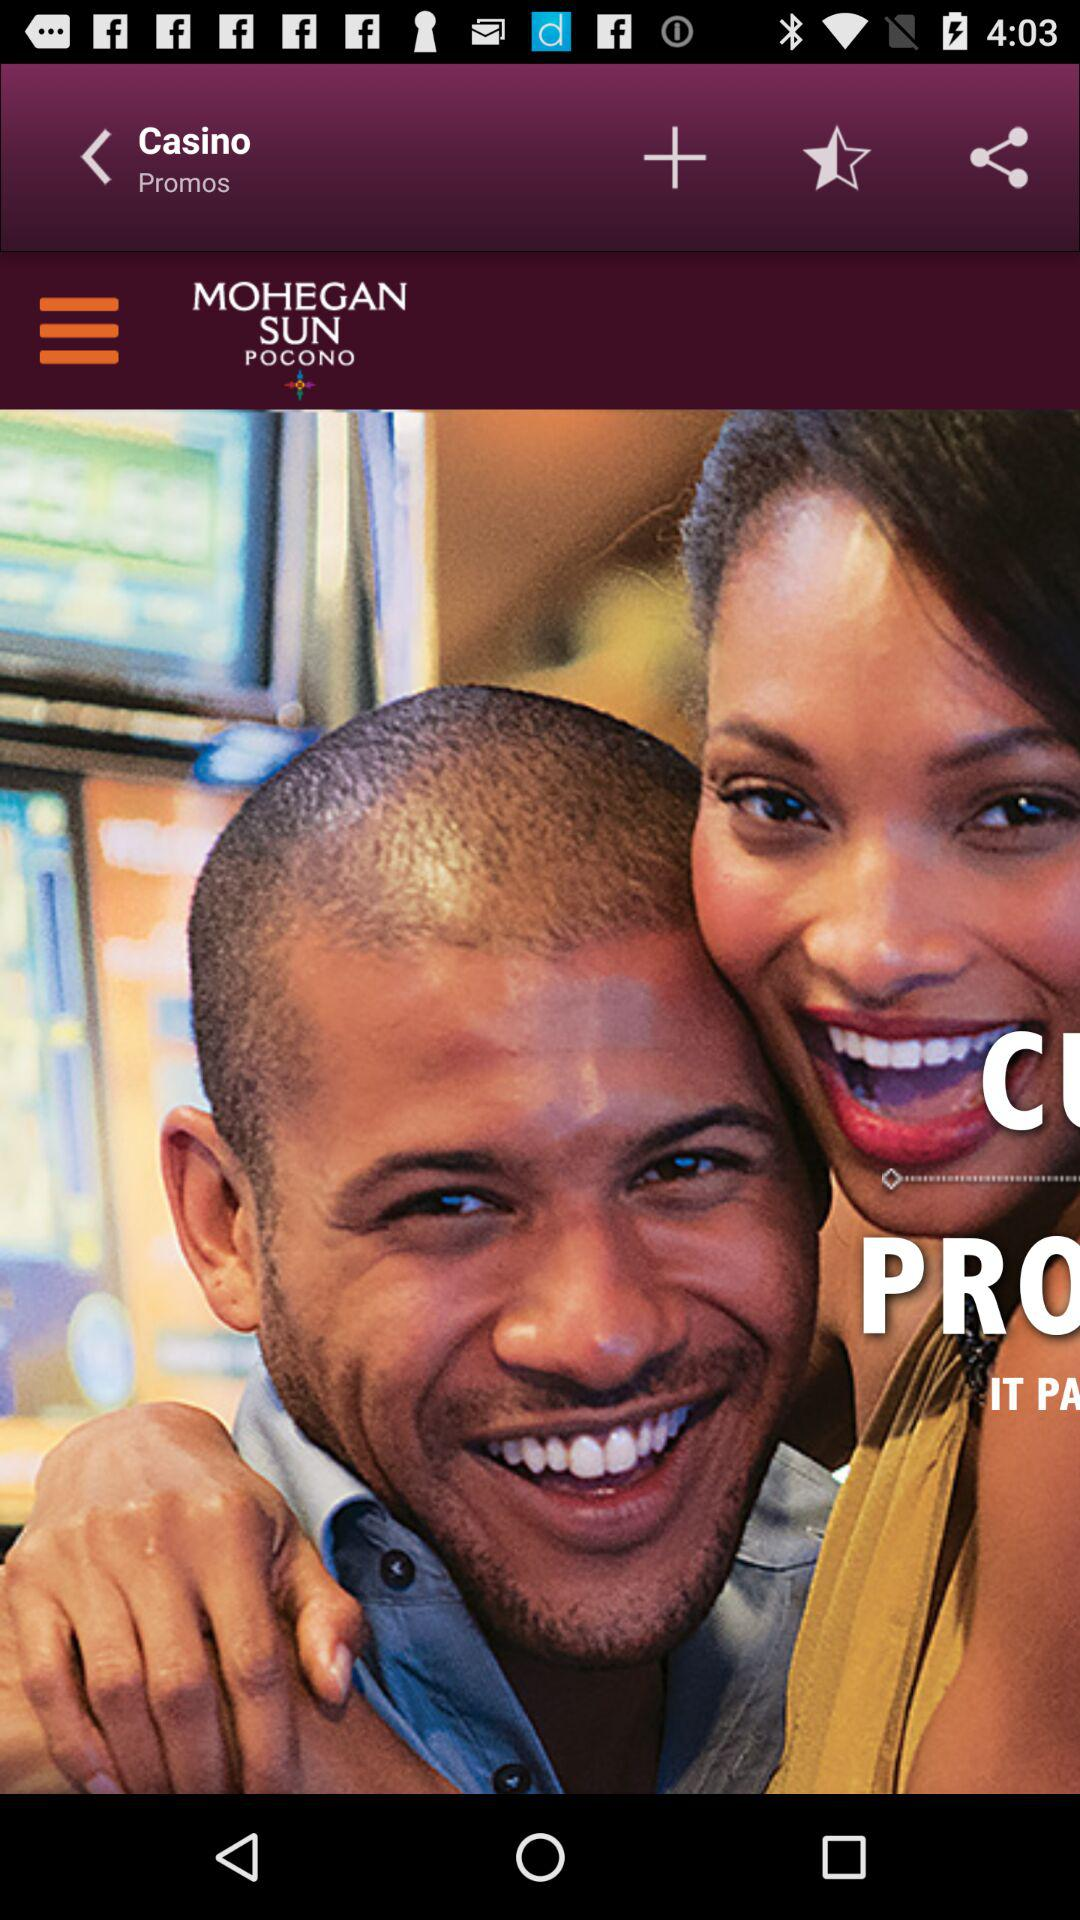How many casinos are listed?
When the provided information is insufficient, respond with <no answer>. <no answer> 